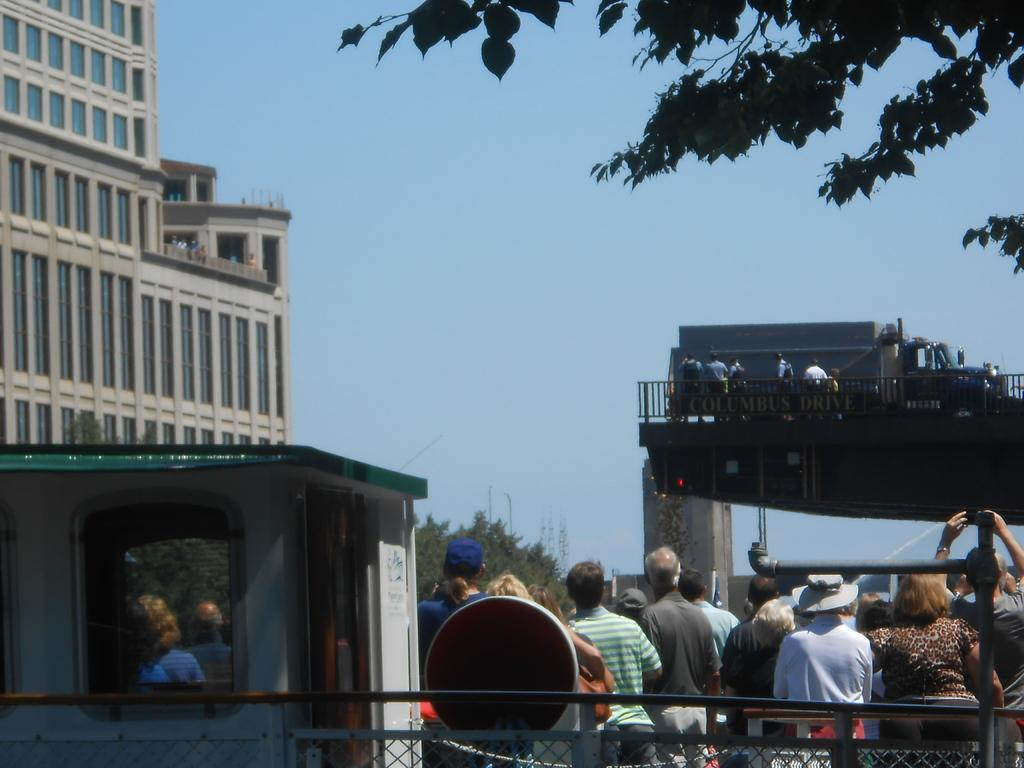How many people are in the image? There is a group of people in the image, but the exact number is not specified. Where are the people located in the image? The people are standing on the road in the image. What can be seen in the background of the image? There is a building visible in the image. Can you describe any other elements in the image? There are other unspecified elements in the image, but their details are not provided. How many chickens are present in the image? There is no mention of chickens in the image, so it is not possible to determine their presence or quantity. 